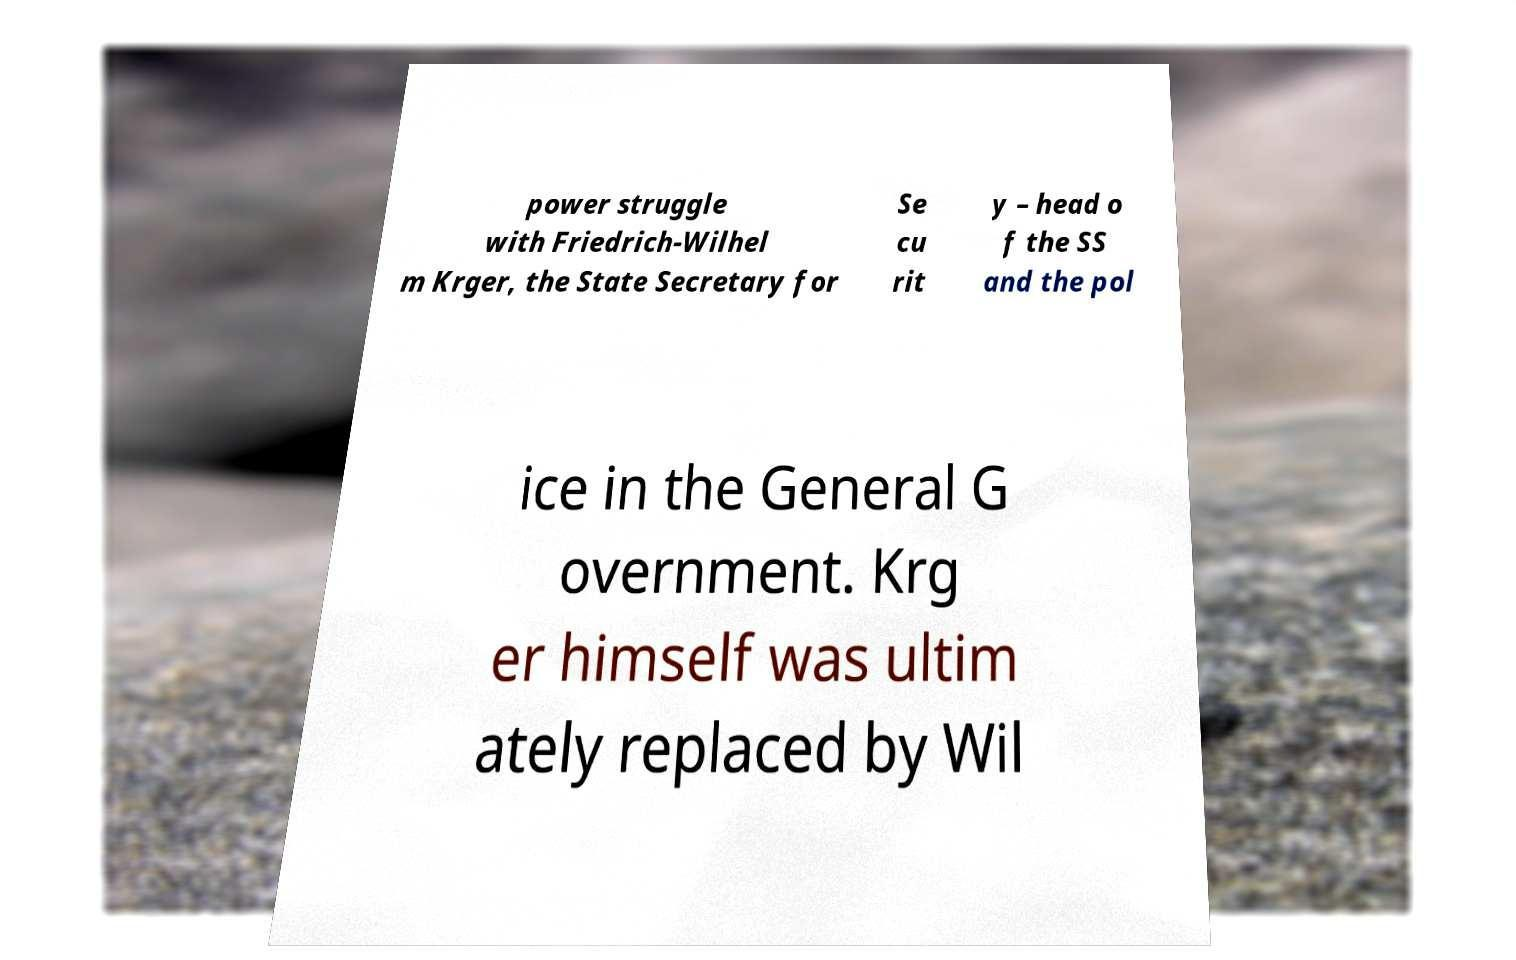I need the written content from this picture converted into text. Can you do that? power struggle with Friedrich-Wilhel m Krger, the State Secretary for Se cu rit y – head o f the SS and the pol ice in the General G overnment. Krg er himself was ultim ately replaced by Wil 